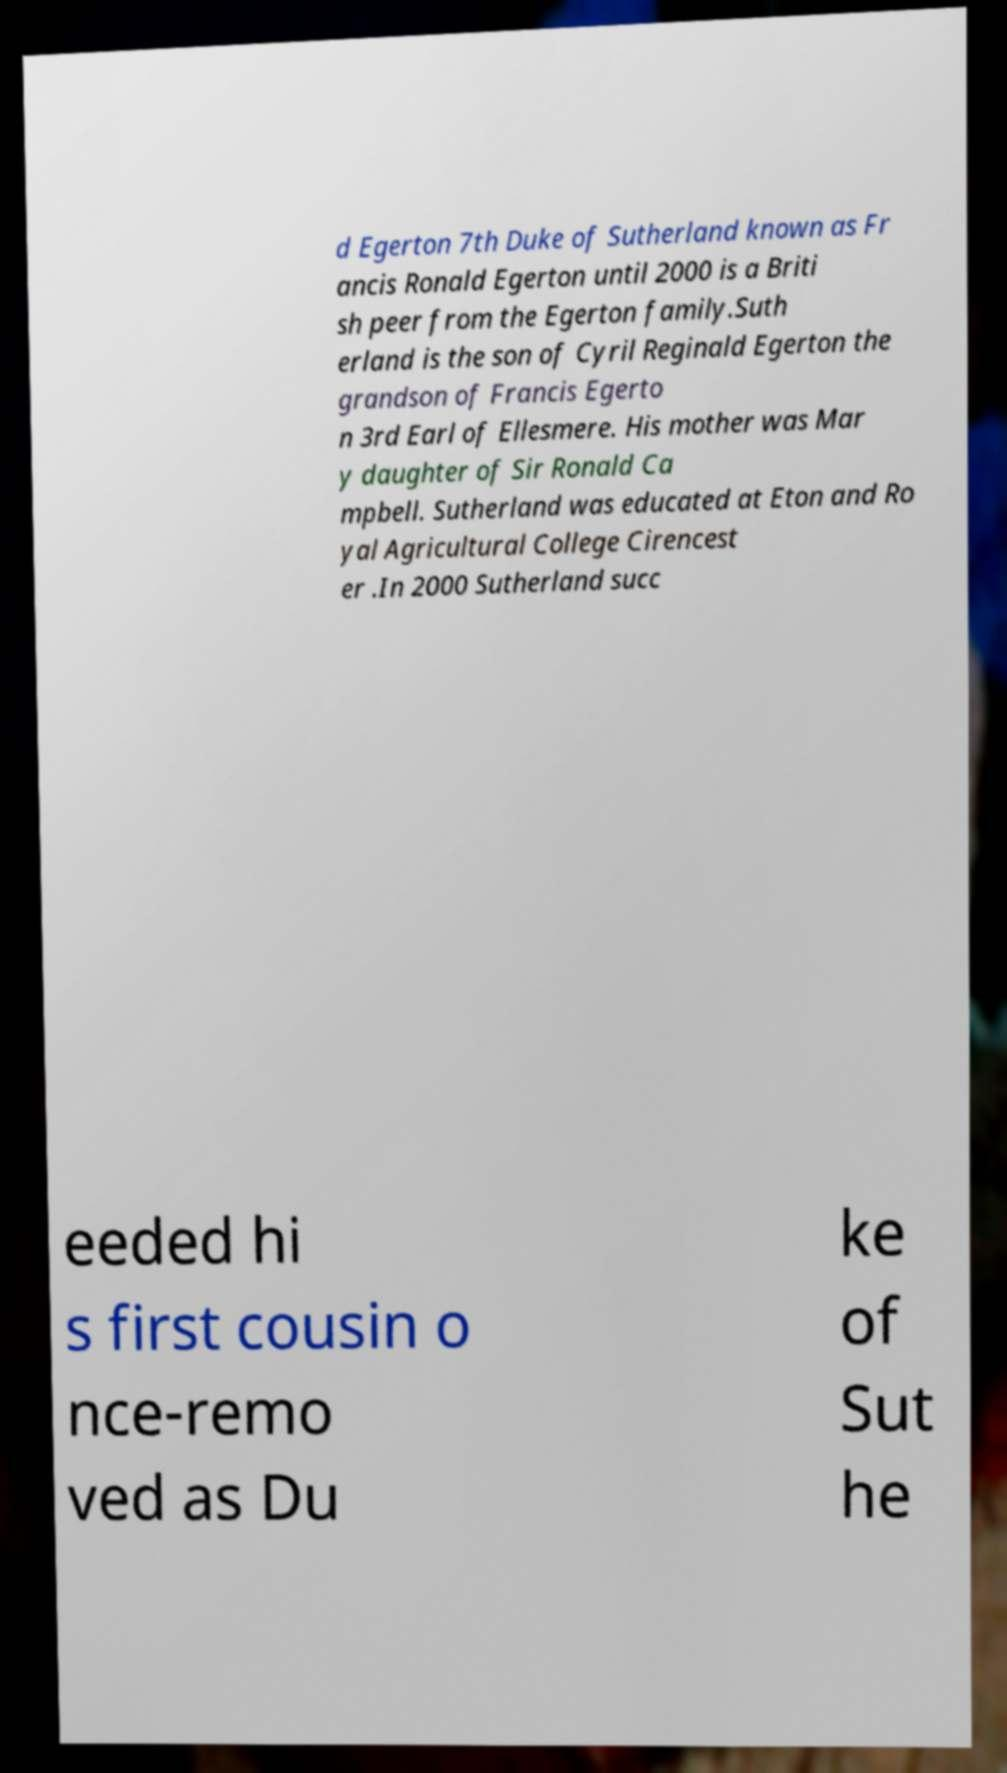Can you read and provide the text displayed in the image?This photo seems to have some interesting text. Can you extract and type it out for me? d Egerton 7th Duke of Sutherland known as Fr ancis Ronald Egerton until 2000 is a Briti sh peer from the Egerton family.Suth erland is the son of Cyril Reginald Egerton the grandson of Francis Egerto n 3rd Earl of Ellesmere. His mother was Mar y daughter of Sir Ronald Ca mpbell. Sutherland was educated at Eton and Ro yal Agricultural College Cirencest er .In 2000 Sutherland succ eeded hi s first cousin o nce-remo ved as Du ke of Sut he 